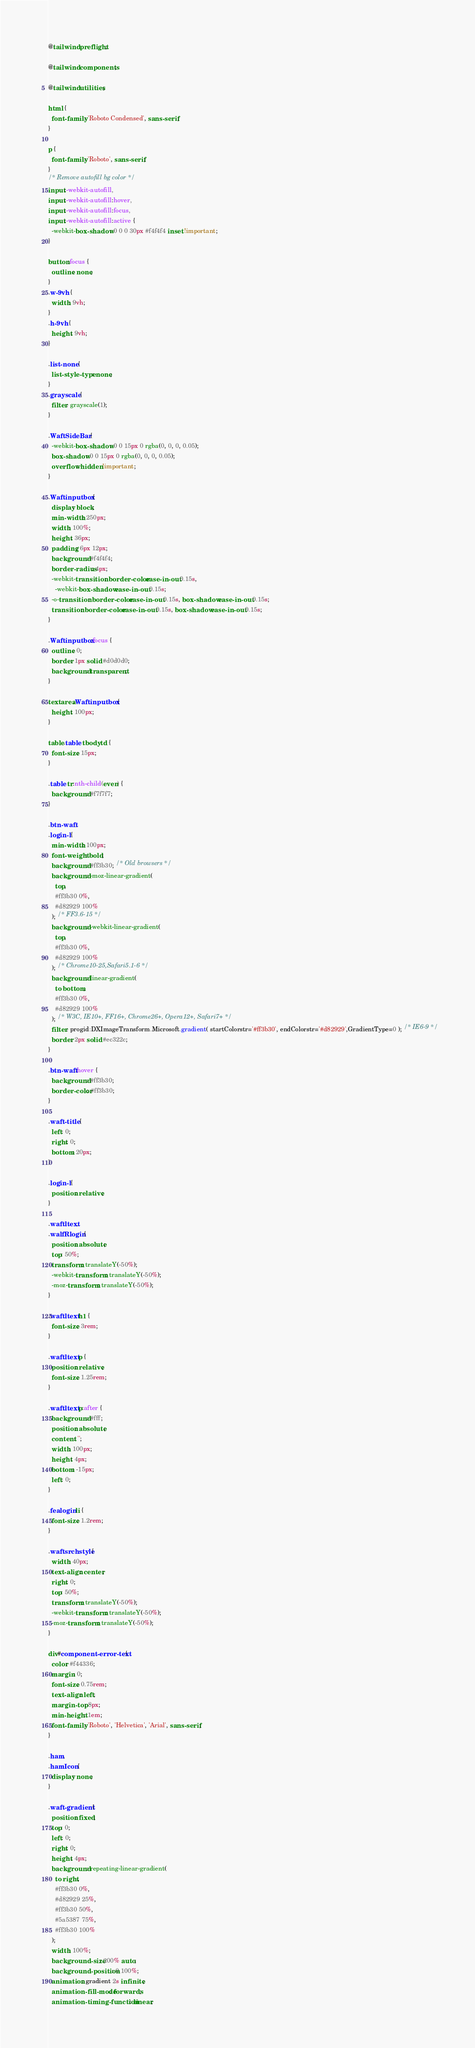Convert code to text. <code><loc_0><loc_0><loc_500><loc_500><_CSS_>@tailwind preflight;

@tailwind components;

@tailwind utilities;

html {
  font-family: 'Roboto Condensed', sans-serif;
}

p {
  font-family: 'Roboto', sans-serif;
}
/* Remove autofill bg color */
input:-webkit-autofill,
input:-webkit-autofill:hover,
input:-webkit-autofill:focus,
input:-webkit-autofill:active {
  -webkit-box-shadow: 0 0 0 30px #f4f4f4 inset !important;
}

button:focus {
  outline: none;
}
.w-9vh {
  width: 9vh;
}
.h-9vh {
  height: 9vh;
}

.list-none {
  list-style-type: none;
}
.grayscale {
  filter: grayscale(1);
}

.WaftSideBar {
  -webkit-box-shadow: 0 0 15px 0 rgba(0, 0, 0, 0.05);
  box-shadow: 0 0 15px 0 rgba(0, 0, 0, 0.05);
  overflow: hidden !important;
}

.Waftinputbox {
  display: block;
  min-width: 250px;
  width: 100%;
  height: 36px;
  padding: 6px 12px;
  background: #f4f4f4;
  border-radius: 4px;
  -webkit-transition: border-color ease-in-out 0.15s,
    -webkit-box-shadow ease-in-out 0.15s;
  -o-transition: border-color ease-in-out 0.15s, box-shadow ease-in-out 0.15s;
  transition: border-color ease-in-out 0.15s, box-shadow ease-in-out 0.15s;
}

.Waftinputbox:focus {
  outline: 0;
  border: 1px solid #d0d0d0;
  background: transparent;
}

textarea.Waftinputbox {
  height: 100px;
}

table.table tbody td {
  font-size: 15px;
}

.table tr:nth-child(even) {
  background: #f7f7f7;
}

.btn-waft,
.login-l {
  min-width: 100px;
  font-weight: bold;
  background: #ff3b30; /* Old browsers */
  background: -moz-linear-gradient(
    top,
    #ff3b30 0%,
    #d82929 100%
  ); /* FF3.6-15 */
  background: -webkit-linear-gradient(
    top,
    #ff3b30 0%,
    #d82929 100%
  ); /* Chrome10-25,Safari5.1-6 */
  background: linear-gradient(
    to bottom,
    #ff3b30 0%,
    #d82929 100%
  ); /* W3C, IE10+, FF16+, Chrome26+, Opera12+, Safari7+ */
  filter: progid:DXImageTransform.Microsoft.gradient( startColorstr='#ff3b30', endColorstr='#d82929',GradientType=0 ); /* IE6-9 */
  border: 2px solid #ec322c;
}

.btn-waft:hover {
  background: #ff3b30;
  border-color: #ff3b30;
}

.waft-title {
  left: 0;
  right: 0;
  bottom: 20px;
}

.login-l {
  position: relative;
}

.waftltext,
.walfRlogin {
  position: absolute;
  top: 50%;
  transform: translateY(-50%);
  -webkit-transform: translateY(-50%);
  -moz-transform: translateY(-50%);
}

.waftltext h1 {
  font-size: 3rem;
}

.waftltext p {
  position: relative;
  font-size: 1.25rem;
}

.waftltext p:after {
  background: #fff;
  position: absolute;
  content: '';
  width: 100px;
  height: 4px;
  bottom: -15px;
  left: 0;
}

.fealogin li {
  font-size: 1.2rem;
}

.waftsrchstyle {
  width: 40px;
  text-align: center;
  right: 0;
  top: 50%;
  transform: translateY(-50%);
  -webkit-transform: translateY(-50%);
  -moz-transform: translateY(-50%);
}

div#component-error-text {
  color: #f44336;
  margin: 0;
  font-size: 0.75rem;
  text-align: left;
  margin-top: 8px;
  min-height: 1em;
  font-family: 'Roboto', 'Helvetica', 'Arial', sans-serif;
}

.ham,
.hamIcon {
  display: none;
}

.waft-gradient {
  position: fixed;
  top: 0;
  left: 0;
  right: 0;
  height: 4px;
  background: repeating-linear-gradient(
    to right,
    #ff3b30 0%,
    #d82929 25%,
    #ff3b30 50%,
    #5a5387 75%,
    #ff3b30 100%
  );
  width: 100%;
  background-size: 200% auto;
  background-position: 0 100%;
  animation: gradient 2s infinite;
  animation-fill-mode: forwards;
  animation-timing-function: linear;</code> 